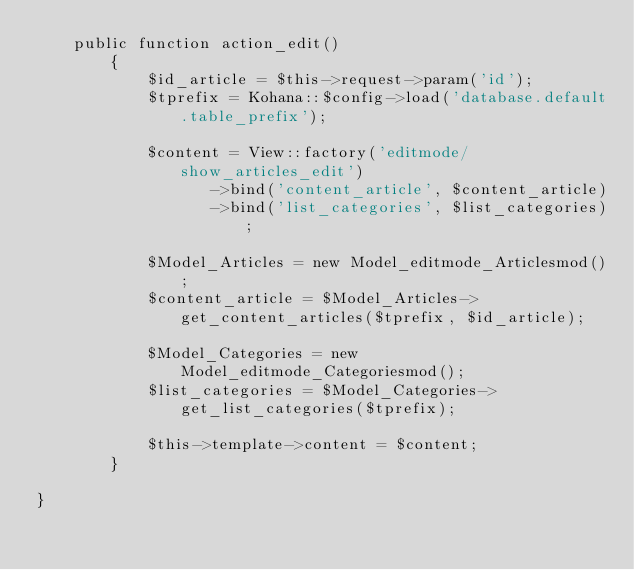Convert code to text. <code><loc_0><loc_0><loc_500><loc_500><_PHP_>	public function action_edit()
		{
			$id_article = $this->request->param('id');
			$tprefix = Kohana::$config->load('database.default.table_prefix');

			$content = View::factory('editmode/show_articles_edit')
				   ->bind('content_article', $content_article)
				   ->bind('list_categories', $list_categories);	
				   
			$Model_Articles = new Model_editmode_Articlesmod();
			$content_article = $Model_Articles->get_content_articles($tprefix, $id_article);
			
			$Model_Categories = new Model_editmode_Categoriesmod();
			$list_categories = $Model_Categories->get_list_categories($tprefix);
		
			$this->template->content = $content;	   
		}	

} 
</code> 